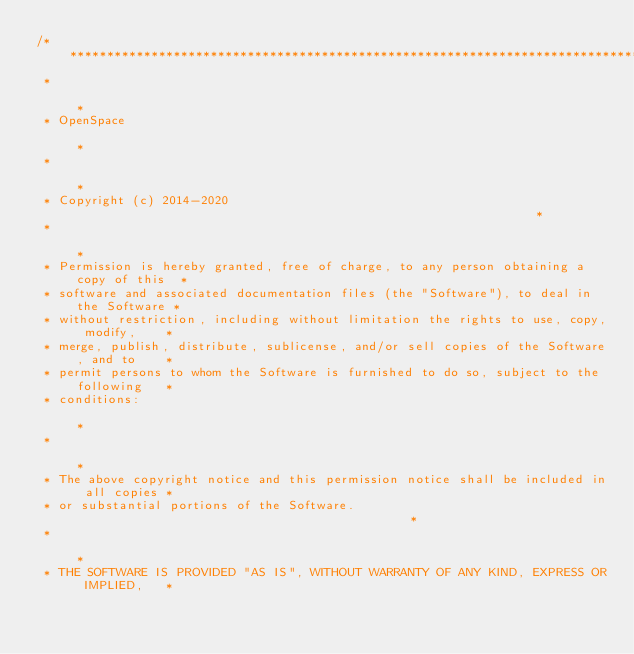Convert code to text. <code><loc_0><loc_0><loc_500><loc_500><_C++_>/*****************************************************************************************
 *                                                                                       *
 * OpenSpace                                                                             *
 *                                                                                       *
 * Copyright (c) 2014-2020                                                               *
 *                                                                                       *
 * Permission is hereby granted, free of charge, to any person obtaining a copy of this  *
 * software and associated documentation files (the "Software"), to deal in the Software *
 * without restriction, including without limitation the rights to use, copy, modify,    *
 * merge, publish, distribute, sublicense, and/or sell copies of the Software, and to    *
 * permit persons to whom the Software is furnished to do so, subject to the following   *
 * conditions:                                                                           *
 *                                                                                       *
 * The above copyright notice and this permission notice shall be included in all copies *
 * or substantial portions of the Software.                                              *
 *                                                                                       *
 * THE SOFTWARE IS PROVIDED "AS IS", WITHOUT WARRANTY OF ANY KIND, EXPRESS OR IMPLIED,   *</code> 